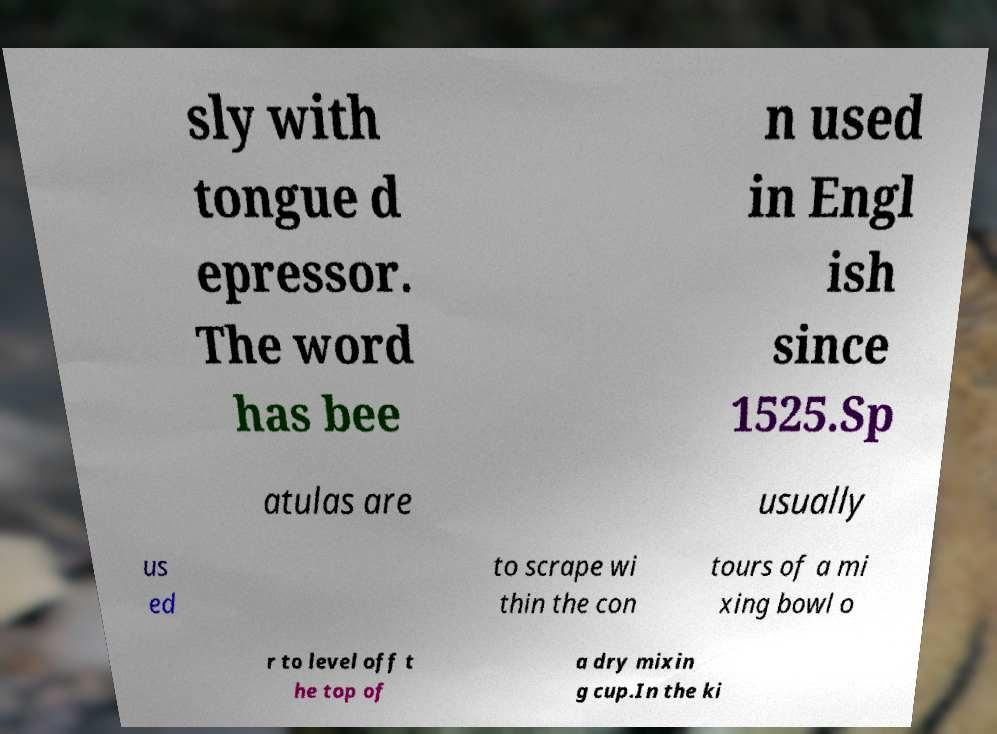Can you read and provide the text displayed in the image?This photo seems to have some interesting text. Can you extract and type it out for me? sly with tongue d epressor. The word has bee n used in Engl ish since 1525.Sp atulas are usually us ed to scrape wi thin the con tours of a mi xing bowl o r to level off t he top of a dry mixin g cup.In the ki 